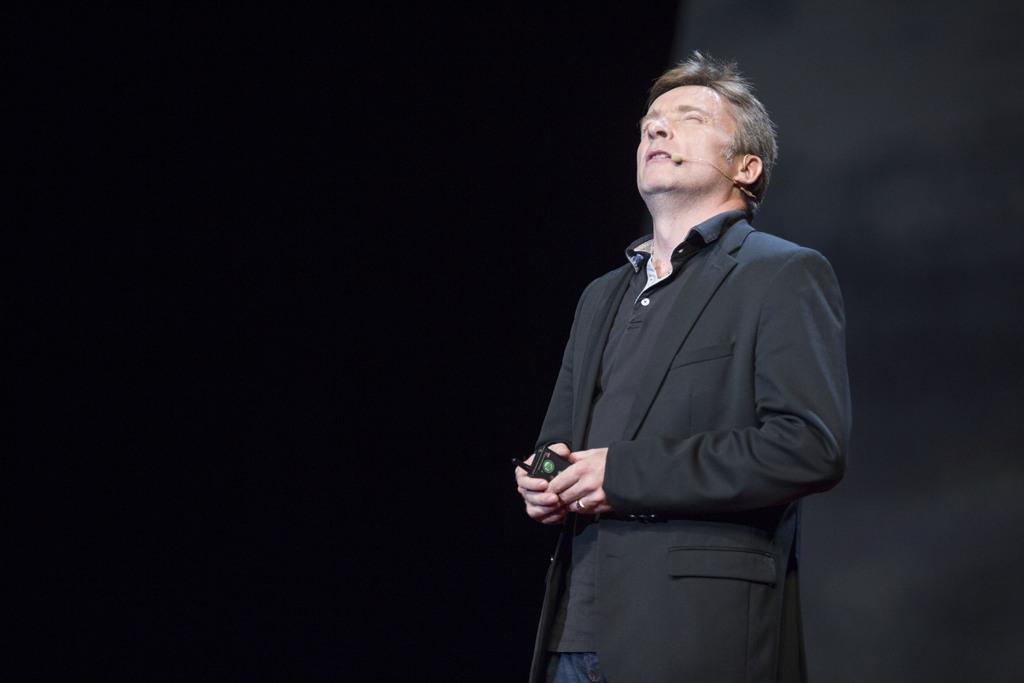Describe this image in one or two sentences. On the right side of the image a man is standing and holding an object and wearing a mic. 